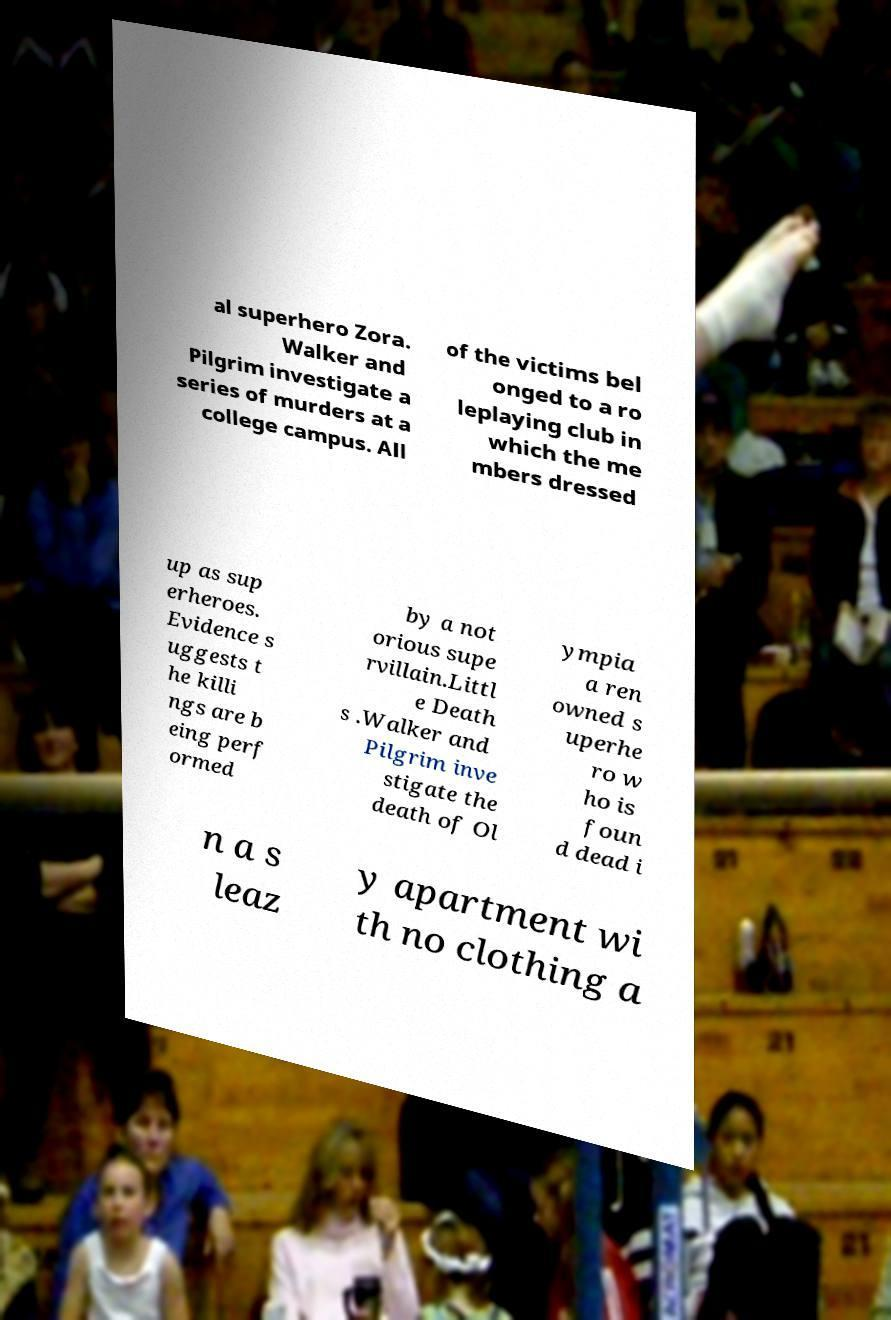Can you read and provide the text displayed in the image?This photo seems to have some interesting text. Can you extract and type it out for me? al superhero Zora. Walker and Pilgrim investigate a series of murders at a college campus. All of the victims bel onged to a ro leplaying club in which the me mbers dressed up as sup erheroes. Evidence s uggests t he killi ngs are b eing perf ormed by a not orious supe rvillain.Littl e Death s .Walker and Pilgrim inve stigate the death of Ol ympia a ren owned s uperhe ro w ho is foun d dead i n a s leaz y apartment wi th no clothing a 